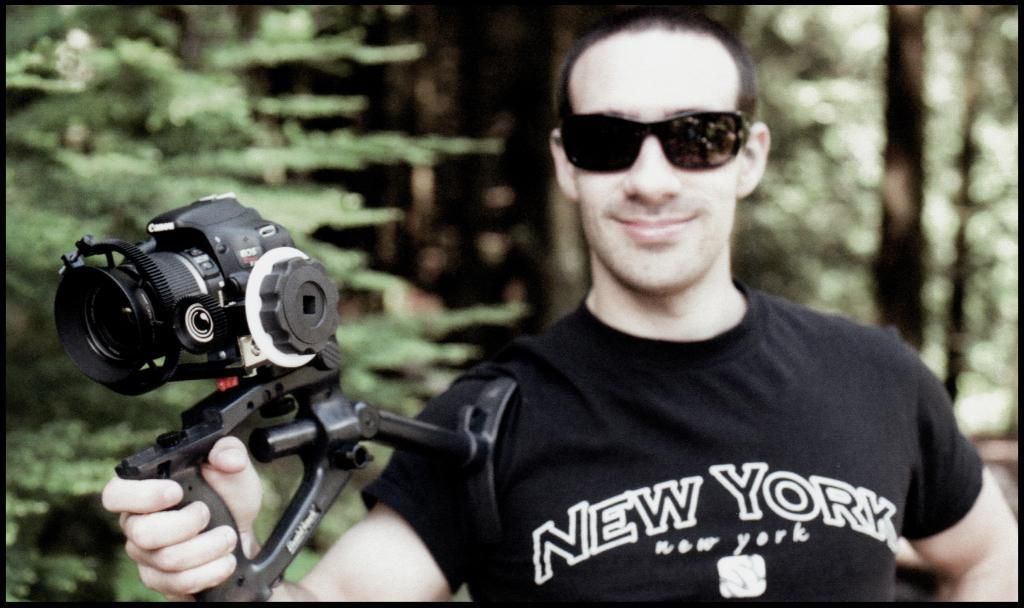What is the main subject in the foreground of the picture? There is a man in the foreground of the picture. What is the man wearing? The man is wearing a black T-shirt. What is the man holding in his hand? The man is holding a camera in his hand. What type of eyewear is the man wearing? The man is wearing black spectacles. What can be seen in the background of the picture? There are trees in the background of the picture. Can you tell me how many hens are visible in the picture? There are no hens present in the picture; it features a man holding a camera in the foreground and trees in the background. Is the man in the picture kicking a soccer ball? There is no soccer ball or any indication of kicking in the picture; the man is holding a camera. 